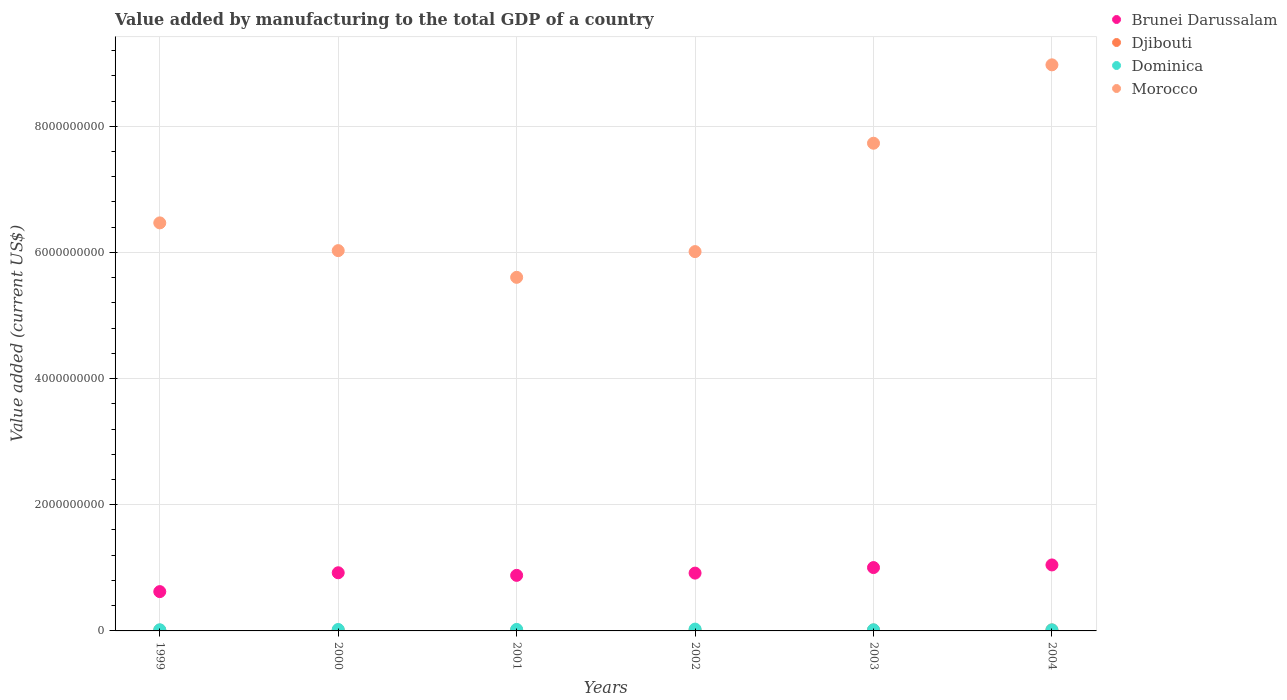What is the value added by manufacturing to the total GDP in Dominica in 2000?
Make the answer very short. 2.29e+07. Across all years, what is the maximum value added by manufacturing to the total GDP in Dominica?
Your response must be concise. 2.89e+07. Across all years, what is the minimum value added by manufacturing to the total GDP in Djibouti?
Your answer should be very brief. 1.21e+07. In which year was the value added by manufacturing to the total GDP in Brunei Darussalam maximum?
Offer a terse response. 2004. What is the total value added by manufacturing to the total GDP in Brunei Darussalam in the graph?
Ensure brevity in your answer.  5.39e+09. What is the difference between the value added by manufacturing to the total GDP in Brunei Darussalam in 2003 and that in 2004?
Your answer should be compact. -4.17e+07. What is the difference between the value added by manufacturing to the total GDP in Djibouti in 1999 and the value added by manufacturing to the total GDP in Morocco in 2001?
Ensure brevity in your answer.  -5.59e+09. What is the average value added by manufacturing to the total GDP in Brunei Darussalam per year?
Your response must be concise. 8.99e+08. In the year 1999, what is the difference between the value added by manufacturing to the total GDP in Dominica and value added by manufacturing to the total GDP in Morocco?
Provide a succinct answer. -6.45e+09. In how many years, is the value added by manufacturing to the total GDP in Dominica greater than 5200000000 US$?
Your answer should be very brief. 0. What is the ratio of the value added by manufacturing to the total GDP in Djibouti in 1999 to that in 2003?
Give a very brief answer. 0.84. What is the difference between the highest and the second highest value added by manufacturing to the total GDP in Dominica?
Provide a short and direct response. 4.72e+06. What is the difference between the highest and the lowest value added by manufacturing to the total GDP in Dominica?
Offer a very short reply. 1.19e+07. Is the sum of the value added by manufacturing to the total GDP in Djibouti in 2001 and 2004 greater than the maximum value added by manufacturing to the total GDP in Dominica across all years?
Ensure brevity in your answer.  No. Does the value added by manufacturing to the total GDP in Djibouti monotonically increase over the years?
Offer a very short reply. Yes. Is the value added by manufacturing to the total GDP in Djibouti strictly greater than the value added by manufacturing to the total GDP in Dominica over the years?
Keep it short and to the point. No. Is the value added by manufacturing to the total GDP in Morocco strictly less than the value added by manufacturing to the total GDP in Djibouti over the years?
Give a very brief answer. No. How many years are there in the graph?
Offer a terse response. 6. Does the graph contain any zero values?
Your answer should be very brief. No. Does the graph contain grids?
Keep it short and to the point. Yes. What is the title of the graph?
Provide a succinct answer. Value added by manufacturing to the total GDP of a country. What is the label or title of the Y-axis?
Provide a short and direct response. Value added (current US$). What is the Value added (current US$) of Brunei Darussalam in 1999?
Offer a very short reply. 6.23e+08. What is the Value added (current US$) of Djibouti in 1999?
Offer a terse response. 1.21e+07. What is the Value added (current US$) in Dominica in 1999?
Provide a succinct answer. 1.83e+07. What is the Value added (current US$) of Morocco in 1999?
Your answer should be very brief. 6.47e+09. What is the Value added (current US$) of Brunei Darussalam in 2000?
Keep it short and to the point. 9.22e+08. What is the Value added (current US$) of Djibouti in 2000?
Your response must be concise. 1.26e+07. What is the Value added (current US$) in Dominica in 2000?
Your answer should be very brief. 2.29e+07. What is the Value added (current US$) of Morocco in 2000?
Offer a terse response. 6.03e+09. What is the Value added (current US$) in Brunei Darussalam in 2001?
Your answer should be compact. 8.81e+08. What is the Value added (current US$) in Djibouti in 2001?
Provide a short and direct response. 1.32e+07. What is the Value added (current US$) of Dominica in 2001?
Make the answer very short. 2.42e+07. What is the Value added (current US$) of Morocco in 2001?
Keep it short and to the point. 5.61e+09. What is the Value added (current US$) of Brunei Darussalam in 2002?
Give a very brief answer. 9.16e+08. What is the Value added (current US$) of Djibouti in 2002?
Your answer should be very brief. 1.37e+07. What is the Value added (current US$) of Dominica in 2002?
Give a very brief answer. 2.89e+07. What is the Value added (current US$) of Morocco in 2002?
Keep it short and to the point. 6.01e+09. What is the Value added (current US$) of Brunei Darussalam in 2003?
Give a very brief answer. 1.00e+09. What is the Value added (current US$) in Djibouti in 2003?
Offer a very short reply. 1.44e+07. What is the Value added (current US$) of Dominica in 2003?
Offer a terse response. 1.80e+07. What is the Value added (current US$) in Morocco in 2003?
Provide a short and direct response. 7.73e+09. What is the Value added (current US$) in Brunei Darussalam in 2004?
Make the answer very short. 1.05e+09. What is the Value added (current US$) in Djibouti in 2004?
Provide a succinct answer. 1.54e+07. What is the Value added (current US$) in Dominica in 2004?
Give a very brief answer. 1.70e+07. What is the Value added (current US$) of Morocco in 2004?
Offer a terse response. 8.97e+09. Across all years, what is the maximum Value added (current US$) in Brunei Darussalam?
Make the answer very short. 1.05e+09. Across all years, what is the maximum Value added (current US$) in Djibouti?
Ensure brevity in your answer.  1.54e+07. Across all years, what is the maximum Value added (current US$) of Dominica?
Give a very brief answer. 2.89e+07. Across all years, what is the maximum Value added (current US$) of Morocco?
Make the answer very short. 8.97e+09. Across all years, what is the minimum Value added (current US$) in Brunei Darussalam?
Offer a terse response. 6.23e+08. Across all years, what is the minimum Value added (current US$) of Djibouti?
Ensure brevity in your answer.  1.21e+07. Across all years, what is the minimum Value added (current US$) in Dominica?
Offer a terse response. 1.70e+07. Across all years, what is the minimum Value added (current US$) in Morocco?
Make the answer very short. 5.61e+09. What is the total Value added (current US$) in Brunei Darussalam in the graph?
Your response must be concise. 5.39e+09. What is the total Value added (current US$) of Djibouti in the graph?
Your answer should be very brief. 8.13e+07. What is the total Value added (current US$) of Dominica in the graph?
Make the answer very short. 1.29e+08. What is the total Value added (current US$) of Morocco in the graph?
Keep it short and to the point. 4.08e+1. What is the difference between the Value added (current US$) in Brunei Darussalam in 1999 and that in 2000?
Provide a succinct answer. -2.99e+08. What is the difference between the Value added (current US$) of Djibouti in 1999 and that in 2000?
Provide a short and direct response. -4.83e+05. What is the difference between the Value added (current US$) in Dominica in 1999 and that in 2000?
Provide a succinct answer. -4.63e+06. What is the difference between the Value added (current US$) in Morocco in 1999 and that in 2000?
Provide a succinct answer. 4.40e+08. What is the difference between the Value added (current US$) of Brunei Darussalam in 1999 and that in 2001?
Offer a very short reply. -2.58e+08. What is the difference between the Value added (current US$) of Djibouti in 1999 and that in 2001?
Provide a short and direct response. -1.10e+06. What is the difference between the Value added (current US$) of Dominica in 1999 and that in 2001?
Offer a terse response. -5.92e+06. What is the difference between the Value added (current US$) in Morocco in 1999 and that in 2001?
Your answer should be compact. 8.63e+08. What is the difference between the Value added (current US$) of Brunei Darussalam in 1999 and that in 2002?
Provide a short and direct response. -2.93e+08. What is the difference between the Value added (current US$) of Djibouti in 1999 and that in 2002?
Your response must be concise. -1.60e+06. What is the difference between the Value added (current US$) in Dominica in 1999 and that in 2002?
Keep it short and to the point. -1.06e+07. What is the difference between the Value added (current US$) in Morocco in 1999 and that in 2002?
Your answer should be very brief. 4.55e+08. What is the difference between the Value added (current US$) in Brunei Darussalam in 1999 and that in 2003?
Your response must be concise. -3.81e+08. What is the difference between the Value added (current US$) of Djibouti in 1999 and that in 2003?
Provide a short and direct response. -2.30e+06. What is the difference between the Value added (current US$) in Dominica in 1999 and that in 2003?
Offer a very short reply. 2.37e+05. What is the difference between the Value added (current US$) in Morocco in 1999 and that in 2003?
Your response must be concise. -1.26e+09. What is the difference between the Value added (current US$) of Brunei Darussalam in 1999 and that in 2004?
Provide a short and direct response. -4.23e+08. What is the difference between the Value added (current US$) in Djibouti in 1999 and that in 2004?
Offer a terse response. -3.34e+06. What is the difference between the Value added (current US$) in Dominica in 1999 and that in 2004?
Ensure brevity in your answer.  1.29e+06. What is the difference between the Value added (current US$) in Morocco in 1999 and that in 2004?
Your answer should be compact. -2.51e+09. What is the difference between the Value added (current US$) in Brunei Darussalam in 2000 and that in 2001?
Provide a succinct answer. 4.12e+07. What is the difference between the Value added (current US$) in Djibouti in 2000 and that in 2001?
Your answer should be very brief. -6.18e+05. What is the difference between the Value added (current US$) of Dominica in 2000 and that in 2001?
Your answer should be compact. -1.28e+06. What is the difference between the Value added (current US$) in Morocco in 2000 and that in 2001?
Give a very brief answer. 4.23e+08. What is the difference between the Value added (current US$) of Brunei Darussalam in 2000 and that in 2002?
Your response must be concise. 5.49e+06. What is the difference between the Value added (current US$) in Djibouti in 2000 and that in 2002?
Give a very brief answer. -1.11e+06. What is the difference between the Value added (current US$) in Dominica in 2000 and that in 2002?
Give a very brief answer. -6.01e+06. What is the difference between the Value added (current US$) in Morocco in 2000 and that in 2002?
Offer a terse response. 1.53e+07. What is the difference between the Value added (current US$) in Brunei Darussalam in 2000 and that in 2003?
Your answer should be very brief. -8.23e+07. What is the difference between the Value added (current US$) of Djibouti in 2000 and that in 2003?
Offer a very short reply. -1.81e+06. What is the difference between the Value added (current US$) of Dominica in 2000 and that in 2003?
Ensure brevity in your answer.  4.87e+06. What is the difference between the Value added (current US$) in Morocco in 2000 and that in 2003?
Provide a succinct answer. -1.70e+09. What is the difference between the Value added (current US$) in Brunei Darussalam in 2000 and that in 2004?
Offer a very short reply. -1.24e+08. What is the difference between the Value added (current US$) in Djibouti in 2000 and that in 2004?
Your answer should be compact. -2.86e+06. What is the difference between the Value added (current US$) in Dominica in 2000 and that in 2004?
Provide a succinct answer. 5.93e+06. What is the difference between the Value added (current US$) in Morocco in 2000 and that in 2004?
Your answer should be compact. -2.95e+09. What is the difference between the Value added (current US$) of Brunei Darussalam in 2001 and that in 2002?
Provide a succinct answer. -3.57e+07. What is the difference between the Value added (current US$) of Djibouti in 2001 and that in 2002?
Your answer should be compact. -4.95e+05. What is the difference between the Value added (current US$) of Dominica in 2001 and that in 2002?
Make the answer very short. -4.72e+06. What is the difference between the Value added (current US$) in Morocco in 2001 and that in 2002?
Provide a succinct answer. -4.08e+08. What is the difference between the Value added (current US$) in Brunei Darussalam in 2001 and that in 2003?
Offer a terse response. -1.23e+08. What is the difference between the Value added (current US$) of Djibouti in 2001 and that in 2003?
Your answer should be compact. -1.20e+06. What is the difference between the Value added (current US$) in Dominica in 2001 and that in 2003?
Offer a very short reply. 6.16e+06. What is the difference between the Value added (current US$) in Morocco in 2001 and that in 2003?
Your answer should be compact. -2.13e+09. What is the difference between the Value added (current US$) of Brunei Darussalam in 2001 and that in 2004?
Provide a succinct answer. -1.65e+08. What is the difference between the Value added (current US$) of Djibouti in 2001 and that in 2004?
Make the answer very short. -2.24e+06. What is the difference between the Value added (current US$) in Dominica in 2001 and that in 2004?
Your answer should be compact. 7.21e+06. What is the difference between the Value added (current US$) in Morocco in 2001 and that in 2004?
Your response must be concise. -3.37e+09. What is the difference between the Value added (current US$) of Brunei Darussalam in 2002 and that in 2003?
Your answer should be very brief. -8.78e+07. What is the difference between the Value added (current US$) of Djibouti in 2002 and that in 2003?
Your response must be concise. -7.02e+05. What is the difference between the Value added (current US$) of Dominica in 2002 and that in 2003?
Offer a terse response. 1.09e+07. What is the difference between the Value added (current US$) of Morocco in 2002 and that in 2003?
Offer a terse response. -1.72e+09. What is the difference between the Value added (current US$) in Brunei Darussalam in 2002 and that in 2004?
Ensure brevity in your answer.  -1.30e+08. What is the difference between the Value added (current US$) in Djibouti in 2002 and that in 2004?
Offer a terse response. -1.75e+06. What is the difference between the Value added (current US$) in Dominica in 2002 and that in 2004?
Your answer should be very brief. 1.19e+07. What is the difference between the Value added (current US$) in Morocco in 2002 and that in 2004?
Your answer should be compact. -2.96e+09. What is the difference between the Value added (current US$) in Brunei Darussalam in 2003 and that in 2004?
Your response must be concise. -4.17e+07. What is the difference between the Value added (current US$) in Djibouti in 2003 and that in 2004?
Give a very brief answer. -1.04e+06. What is the difference between the Value added (current US$) in Dominica in 2003 and that in 2004?
Your answer should be compact. 1.06e+06. What is the difference between the Value added (current US$) in Morocco in 2003 and that in 2004?
Provide a succinct answer. -1.24e+09. What is the difference between the Value added (current US$) of Brunei Darussalam in 1999 and the Value added (current US$) of Djibouti in 2000?
Ensure brevity in your answer.  6.11e+08. What is the difference between the Value added (current US$) of Brunei Darussalam in 1999 and the Value added (current US$) of Dominica in 2000?
Ensure brevity in your answer.  6.00e+08. What is the difference between the Value added (current US$) of Brunei Darussalam in 1999 and the Value added (current US$) of Morocco in 2000?
Your answer should be compact. -5.41e+09. What is the difference between the Value added (current US$) in Djibouti in 1999 and the Value added (current US$) in Dominica in 2000?
Make the answer very short. -1.08e+07. What is the difference between the Value added (current US$) in Djibouti in 1999 and the Value added (current US$) in Morocco in 2000?
Your answer should be very brief. -6.02e+09. What is the difference between the Value added (current US$) of Dominica in 1999 and the Value added (current US$) of Morocco in 2000?
Your response must be concise. -6.01e+09. What is the difference between the Value added (current US$) of Brunei Darussalam in 1999 and the Value added (current US$) of Djibouti in 2001?
Provide a succinct answer. 6.10e+08. What is the difference between the Value added (current US$) of Brunei Darussalam in 1999 and the Value added (current US$) of Dominica in 2001?
Give a very brief answer. 5.99e+08. What is the difference between the Value added (current US$) in Brunei Darussalam in 1999 and the Value added (current US$) in Morocco in 2001?
Offer a very short reply. -4.98e+09. What is the difference between the Value added (current US$) in Djibouti in 1999 and the Value added (current US$) in Dominica in 2001?
Offer a very short reply. -1.21e+07. What is the difference between the Value added (current US$) in Djibouti in 1999 and the Value added (current US$) in Morocco in 2001?
Provide a short and direct response. -5.59e+09. What is the difference between the Value added (current US$) of Dominica in 1999 and the Value added (current US$) of Morocco in 2001?
Keep it short and to the point. -5.59e+09. What is the difference between the Value added (current US$) in Brunei Darussalam in 1999 and the Value added (current US$) in Djibouti in 2002?
Your answer should be very brief. 6.09e+08. What is the difference between the Value added (current US$) of Brunei Darussalam in 1999 and the Value added (current US$) of Dominica in 2002?
Offer a terse response. 5.94e+08. What is the difference between the Value added (current US$) in Brunei Darussalam in 1999 and the Value added (current US$) in Morocco in 2002?
Your response must be concise. -5.39e+09. What is the difference between the Value added (current US$) of Djibouti in 1999 and the Value added (current US$) of Dominica in 2002?
Provide a short and direct response. -1.68e+07. What is the difference between the Value added (current US$) of Djibouti in 1999 and the Value added (current US$) of Morocco in 2002?
Ensure brevity in your answer.  -6.00e+09. What is the difference between the Value added (current US$) of Dominica in 1999 and the Value added (current US$) of Morocco in 2002?
Offer a very short reply. -6.00e+09. What is the difference between the Value added (current US$) in Brunei Darussalam in 1999 and the Value added (current US$) in Djibouti in 2003?
Offer a very short reply. 6.09e+08. What is the difference between the Value added (current US$) in Brunei Darussalam in 1999 and the Value added (current US$) in Dominica in 2003?
Keep it short and to the point. 6.05e+08. What is the difference between the Value added (current US$) of Brunei Darussalam in 1999 and the Value added (current US$) of Morocco in 2003?
Your answer should be compact. -7.11e+09. What is the difference between the Value added (current US$) of Djibouti in 1999 and the Value added (current US$) of Dominica in 2003?
Your answer should be very brief. -5.94e+06. What is the difference between the Value added (current US$) in Djibouti in 1999 and the Value added (current US$) in Morocco in 2003?
Your response must be concise. -7.72e+09. What is the difference between the Value added (current US$) in Dominica in 1999 and the Value added (current US$) in Morocco in 2003?
Provide a short and direct response. -7.71e+09. What is the difference between the Value added (current US$) of Brunei Darussalam in 1999 and the Value added (current US$) of Djibouti in 2004?
Make the answer very short. 6.08e+08. What is the difference between the Value added (current US$) of Brunei Darussalam in 1999 and the Value added (current US$) of Dominica in 2004?
Your response must be concise. 6.06e+08. What is the difference between the Value added (current US$) in Brunei Darussalam in 1999 and the Value added (current US$) in Morocco in 2004?
Provide a short and direct response. -8.35e+09. What is the difference between the Value added (current US$) of Djibouti in 1999 and the Value added (current US$) of Dominica in 2004?
Offer a very short reply. -4.88e+06. What is the difference between the Value added (current US$) of Djibouti in 1999 and the Value added (current US$) of Morocco in 2004?
Keep it short and to the point. -8.96e+09. What is the difference between the Value added (current US$) of Dominica in 1999 and the Value added (current US$) of Morocco in 2004?
Ensure brevity in your answer.  -8.96e+09. What is the difference between the Value added (current US$) of Brunei Darussalam in 2000 and the Value added (current US$) of Djibouti in 2001?
Your answer should be compact. 9.09e+08. What is the difference between the Value added (current US$) of Brunei Darussalam in 2000 and the Value added (current US$) of Dominica in 2001?
Your response must be concise. 8.98e+08. What is the difference between the Value added (current US$) in Brunei Darussalam in 2000 and the Value added (current US$) in Morocco in 2001?
Keep it short and to the point. -4.68e+09. What is the difference between the Value added (current US$) of Djibouti in 2000 and the Value added (current US$) of Dominica in 2001?
Your answer should be compact. -1.16e+07. What is the difference between the Value added (current US$) in Djibouti in 2000 and the Value added (current US$) in Morocco in 2001?
Ensure brevity in your answer.  -5.59e+09. What is the difference between the Value added (current US$) of Dominica in 2000 and the Value added (current US$) of Morocco in 2001?
Ensure brevity in your answer.  -5.58e+09. What is the difference between the Value added (current US$) of Brunei Darussalam in 2000 and the Value added (current US$) of Djibouti in 2002?
Give a very brief answer. 9.08e+08. What is the difference between the Value added (current US$) of Brunei Darussalam in 2000 and the Value added (current US$) of Dominica in 2002?
Provide a short and direct response. 8.93e+08. What is the difference between the Value added (current US$) in Brunei Darussalam in 2000 and the Value added (current US$) in Morocco in 2002?
Your answer should be compact. -5.09e+09. What is the difference between the Value added (current US$) in Djibouti in 2000 and the Value added (current US$) in Dominica in 2002?
Provide a short and direct response. -1.63e+07. What is the difference between the Value added (current US$) of Djibouti in 2000 and the Value added (current US$) of Morocco in 2002?
Keep it short and to the point. -6.00e+09. What is the difference between the Value added (current US$) of Dominica in 2000 and the Value added (current US$) of Morocco in 2002?
Your response must be concise. -5.99e+09. What is the difference between the Value added (current US$) in Brunei Darussalam in 2000 and the Value added (current US$) in Djibouti in 2003?
Keep it short and to the point. 9.08e+08. What is the difference between the Value added (current US$) of Brunei Darussalam in 2000 and the Value added (current US$) of Dominica in 2003?
Provide a short and direct response. 9.04e+08. What is the difference between the Value added (current US$) in Brunei Darussalam in 2000 and the Value added (current US$) in Morocco in 2003?
Ensure brevity in your answer.  -6.81e+09. What is the difference between the Value added (current US$) of Djibouti in 2000 and the Value added (current US$) of Dominica in 2003?
Your answer should be compact. -5.45e+06. What is the difference between the Value added (current US$) of Djibouti in 2000 and the Value added (current US$) of Morocco in 2003?
Make the answer very short. -7.72e+09. What is the difference between the Value added (current US$) in Dominica in 2000 and the Value added (current US$) in Morocco in 2003?
Your answer should be compact. -7.71e+09. What is the difference between the Value added (current US$) in Brunei Darussalam in 2000 and the Value added (current US$) in Djibouti in 2004?
Ensure brevity in your answer.  9.07e+08. What is the difference between the Value added (current US$) in Brunei Darussalam in 2000 and the Value added (current US$) in Dominica in 2004?
Your answer should be very brief. 9.05e+08. What is the difference between the Value added (current US$) of Brunei Darussalam in 2000 and the Value added (current US$) of Morocco in 2004?
Offer a terse response. -8.05e+09. What is the difference between the Value added (current US$) of Djibouti in 2000 and the Value added (current US$) of Dominica in 2004?
Ensure brevity in your answer.  -4.40e+06. What is the difference between the Value added (current US$) of Djibouti in 2000 and the Value added (current US$) of Morocco in 2004?
Offer a very short reply. -8.96e+09. What is the difference between the Value added (current US$) in Dominica in 2000 and the Value added (current US$) in Morocco in 2004?
Offer a very short reply. -8.95e+09. What is the difference between the Value added (current US$) of Brunei Darussalam in 2001 and the Value added (current US$) of Djibouti in 2002?
Offer a terse response. 8.67e+08. What is the difference between the Value added (current US$) in Brunei Darussalam in 2001 and the Value added (current US$) in Dominica in 2002?
Your answer should be compact. 8.52e+08. What is the difference between the Value added (current US$) of Brunei Darussalam in 2001 and the Value added (current US$) of Morocco in 2002?
Ensure brevity in your answer.  -5.13e+09. What is the difference between the Value added (current US$) in Djibouti in 2001 and the Value added (current US$) in Dominica in 2002?
Keep it short and to the point. -1.57e+07. What is the difference between the Value added (current US$) of Djibouti in 2001 and the Value added (current US$) of Morocco in 2002?
Your answer should be compact. -6.00e+09. What is the difference between the Value added (current US$) in Dominica in 2001 and the Value added (current US$) in Morocco in 2002?
Ensure brevity in your answer.  -5.99e+09. What is the difference between the Value added (current US$) in Brunei Darussalam in 2001 and the Value added (current US$) in Djibouti in 2003?
Provide a succinct answer. 8.66e+08. What is the difference between the Value added (current US$) in Brunei Darussalam in 2001 and the Value added (current US$) in Dominica in 2003?
Your response must be concise. 8.63e+08. What is the difference between the Value added (current US$) in Brunei Darussalam in 2001 and the Value added (current US$) in Morocco in 2003?
Your response must be concise. -6.85e+09. What is the difference between the Value added (current US$) in Djibouti in 2001 and the Value added (current US$) in Dominica in 2003?
Your answer should be very brief. -4.83e+06. What is the difference between the Value added (current US$) in Djibouti in 2001 and the Value added (current US$) in Morocco in 2003?
Your answer should be very brief. -7.72e+09. What is the difference between the Value added (current US$) of Dominica in 2001 and the Value added (current US$) of Morocco in 2003?
Offer a very short reply. -7.71e+09. What is the difference between the Value added (current US$) in Brunei Darussalam in 2001 and the Value added (current US$) in Djibouti in 2004?
Make the answer very short. 8.65e+08. What is the difference between the Value added (current US$) in Brunei Darussalam in 2001 and the Value added (current US$) in Dominica in 2004?
Offer a very short reply. 8.64e+08. What is the difference between the Value added (current US$) of Brunei Darussalam in 2001 and the Value added (current US$) of Morocco in 2004?
Give a very brief answer. -8.09e+09. What is the difference between the Value added (current US$) of Djibouti in 2001 and the Value added (current US$) of Dominica in 2004?
Your response must be concise. -3.78e+06. What is the difference between the Value added (current US$) of Djibouti in 2001 and the Value added (current US$) of Morocco in 2004?
Ensure brevity in your answer.  -8.96e+09. What is the difference between the Value added (current US$) of Dominica in 2001 and the Value added (current US$) of Morocco in 2004?
Your response must be concise. -8.95e+09. What is the difference between the Value added (current US$) in Brunei Darussalam in 2002 and the Value added (current US$) in Djibouti in 2003?
Provide a succinct answer. 9.02e+08. What is the difference between the Value added (current US$) of Brunei Darussalam in 2002 and the Value added (current US$) of Dominica in 2003?
Offer a terse response. 8.98e+08. What is the difference between the Value added (current US$) in Brunei Darussalam in 2002 and the Value added (current US$) in Morocco in 2003?
Provide a succinct answer. -6.82e+09. What is the difference between the Value added (current US$) in Djibouti in 2002 and the Value added (current US$) in Dominica in 2003?
Offer a terse response. -4.34e+06. What is the difference between the Value added (current US$) in Djibouti in 2002 and the Value added (current US$) in Morocco in 2003?
Keep it short and to the point. -7.72e+09. What is the difference between the Value added (current US$) in Dominica in 2002 and the Value added (current US$) in Morocco in 2003?
Your answer should be compact. -7.70e+09. What is the difference between the Value added (current US$) of Brunei Darussalam in 2002 and the Value added (current US$) of Djibouti in 2004?
Your answer should be compact. 9.01e+08. What is the difference between the Value added (current US$) in Brunei Darussalam in 2002 and the Value added (current US$) in Dominica in 2004?
Your answer should be very brief. 9.00e+08. What is the difference between the Value added (current US$) of Brunei Darussalam in 2002 and the Value added (current US$) of Morocco in 2004?
Give a very brief answer. -8.06e+09. What is the difference between the Value added (current US$) in Djibouti in 2002 and the Value added (current US$) in Dominica in 2004?
Keep it short and to the point. -3.28e+06. What is the difference between the Value added (current US$) of Djibouti in 2002 and the Value added (current US$) of Morocco in 2004?
Give a very brief answer. -8.96e+09. What is the difference between the Value added (current US$) in Dominica in 2002 and the Value added (current US$) in Morocco in 2004?
Make the answer very short. -8.95e+09. What is the difference between the Value added (current US$) of Brunei Darussalam in 2003 and the Value added (current US$) of Djibouti in 2004?
Keep it short and to the point. 9.89e+08. What is the difference between the Value added (current US$) of Brunei Darussalam in 2003 and the Value added (current US$) of Dominica in 2004?
Provide a short and direct response. 9.87e+08. What is the difference between the Value added (current US$) in Brunei Darussalam in 2003 and the Value added (current US$) in Morocco in 2004?
Provide a succinct answer. -7.97e+09. What is the difference between the Value added (current US$) in Djibouti in 2003 and the Value added (current US$) in Dominica in 2004?
Keep it short and to the point. -2.58e+06. What is the difference between the Value added (current US$) of Djibouti in 2003 and the Value added (current US$) of Morocco in 2004?
Provide a succinct answer. -8.96e+09. What is the difference between the Value added (current US$) in Dominica in 2003 and the Value added (current US$) in Morocco in 2004?
Offer a terse response. -8.96e+09. What is the average Value added (current US$) in Brunei Darussalam per year?
Offer a terse response. 8.99e+08. What is the average Value added (current US$) of Djibouti per year?
Offer a very short reply. 1.36e+07. What is the average Value added (current US$) in Dominica per year?
Your answer should be very brief. 2.15e+07. What is the average Value added (current US$) in Morocco per year?
Your answer should be compact. 6.80e+09. In the year 1999, what is the difference between the Value added (current US$) in Brunei Darussalam and Value added (current US$) in Djibouti?
Provide a short and direct response. 6.11e+08. In the year 1999, what is the difference between the Value added (current US$) of Brunei Darussalam and Value added (current US$) of Dominica?
Your response must be concise. 6.05e+08. In the year 1999, what is the difference between the Value added (current US$) of Brunei Darussalam and Value added (current US$) of Morocco?
Your answer should be compact. -5.85e+09. In the year 1999, what is the difference between the Value added (current US$) in Djibouti and Value added (current US$) in Dominica?
Provide a short and direct response. -6.17e+06. In the year 1999, what is the difference between the Value added (current US$) of Djibouti and Value added (current US$) of Morocco?
Your answer should be very brief. -6.46e+09. In the year 1999, what is the difference between the Value added (current US$) of Dominica and Value added (current US$) of Morocco?
Your response must be concise. -6.45e+09. In the year 2000, what is the difference between the Value added (current US$) of Brunei Darussalam and Value added (current US$) of Djibouti?
Provide a short and direct response. 9.09e+08. In the year 2000, what is the difference between the Value added (current US$) in Brunei Darussalam and Value added (current US$) in Dominica?
Make the answer very short. 8.99e+08. In the year 2000, what is the difference between the Value added (current US$) in Brunei Darussalam and Value added (current US$) in Morocco?
Make the answer very short. -5.11e+09. In the year 2000, what is the difference between the Value added (current US$) of Djibouti and Value added (current US$) of Dominica?
Make the answer very short. -1.03e+07. In the year 2000, what is the difference between the Value added (current US$) in Djibouti and Value added (current US$) in Morocco?
Keep it short and to the point. -6.02e+09. In the year 2000, what is the difference between the Value added (current US$) of Dominica and Value added (current US$) of Morocco?
Your response must be concise. -6.01e+09. In the year 2001, what is the difference between the Value added (current US$) of Brunei Darussalam and Value added (current US$) of Djibouti?
Offer a terse response. 8.68e+08. In the year 2001, what is the difference between the Value added (current US$) of Brunei Darussalam and Value added (current US$) of Dominica?
Offer a terse response. 8.57e+08. In the year 2001, what is the difference between the Value added (current US$) in Brunei Darussalam and Value added (current US$) in Morocco?
Your answer should be very brief. -4.72e+09. In the year 2001, what is the difference between the Value added (current US$) of Djibouti and Value added (current US$) of Dominica?
Provide a succinct answer. -1.10e+07. In the year 2001, what is the difference between the Value added (current US$) in Djibouti and Value added (current US$) in Morocco?
Your response must be concise. -5.59e+09. In the year 2001, what is the difference between the Value added (current US$) in Dominica and Value added (current US$) in Morocco?
Keep it short and to the point. -5.58e+09. In the year 2002, what is the difference between the Value added (current US$) in Brunei Darussalam and Value added (current US$) in Djibouti?
Provide a short and direct response. 9.03e+08. In the year 2002, what is the difference between the Value added (current US$) of Brunei Darussalam and Value added (current US$) of Dominica?
Provide a succinct answer. 8.88e+08. In the year 2002, what is the difference between the Value added (current US$) of Brunei Darussalam and Value added (current US$) of Morocco?
Provide a short and direct response. -5.10e+09. In the year 2002, what is the difference between the Value added (current US$) of Djibouti and Value added (current US$) of Dominica?
Give a very brief answer. -1.52e+07. In the year 2002, what is the difference between the Value added (current US$) of Djibouti and Value added (current US$) of Morocco?
Your answer should be compact. -6.00e+09. In the year 2002, what is the difference between the Value added (current US$) of Dominica and Value added (current US$) of Morocco?
Provide a short and direct response. -5.98e+09. In the year 2003, what is the difference between the Value added (current US$) of Brunei Darussalam and Value added (current US$) of Djibouti?
Your answer should be very brief. 9.90e+08. In the year 2003, what is the difference between the Value added (current US$) of Brunei Darussalam and Value added (current US$) of Dominica?
Provide a succinct answer. 9.86e+08. In the year 2003, what is the difference between the Value added (current US$) in Brunei Darussalam and Value added (current US$) in Morocco?
Your answer should be very brief. -6.73e+09. In the year 2003, what is the difference between the Value added (current US$) of Djibouti and Value added (current US$) of Dominica?
Give a very brief answer. -3.64e+06. In the year 2003, what is the difference between the Value added (current US$) in Djibouti and Value added (current US$) in Morocco?
Make the answer very short. -7.72e+09. In the year 2003, what is the difference between the Value added (current US$) in Dominica and Value added (current US$) in Morocco?
Make the answer very short. -7.71e+09. In the year 2004, what is the difference between the Value added (current US$) of Brunei Darussalam and Value added (current US$) of Djibouti?
Provide a succinct answer. 1.03e+09. In the year 2004, what is the difference between the Value added (current US$) of Brunei Darussalam and Value added (current US$) of Dominica?
Provide a short and direct response. 1.03e+09. In the year 2004, what is the difference between the Value added (current US$) of Brunei Darussalam and Value added (current US$) of Morocco?
Offer a terse response. -7.93e+09. In the year 2004, what is the difference between the Value added (current US$) in Djibouti and Value added (current US$) in Dominica?
Provide a short and direct response. -1.54e+06. In the year 2004, what is the difference between the Value added (current US$) of Djibouti and Value added (current US$) of Morocco?
Offer a terse response. -8.96e+09. In the year 2004, what is the difference between the Value added (current US$) of Dominica and Value added (current US$) of Morocco?
Provide a short and direct response. -8.96e+09. What is the ratio of the Value added (current US$) of Brunei Darussalam in 1999 to that in 2000?
Keep it short and to the point. 0.68. What is the ratio of the Value added (current US$) of Djibouti in 1999 to that in 2000?
Your answer should be very brief. 0.96. What is the ratio of the Value added (current US$) in Dominica in 1999 to that in 2000?
Keep it short and to the point. 0.8. What is the ratio of the Value added (current US$) of Morocco in 1999 to that in 2000?
Your answer should be very brief. 1.07. What is the ratio of the Value added (current US$) of Brunei Darussalam in 1999 to that in 2001?
Provide a succinct answer. 0.71. What is the ratio of the Value added (current US$) in Djibouti in 1999 to that in 2001?
Offer a very short reply. 0.92. What is the ratio of the Value added (current US$) in Dominica in 1999 to that in 2001?
Your answer should be compact. 0.76. What is the ratio of the Value added (current US$) of Morocco in 1999 to that in 2001?
Offer a terse response. 1.15. What is the ratio of the Value added (current US$) of Brunei Darussalam in 1999 to that in 2002?
Provide a short and direct response. 0.68. What is the ratio of the Value added (current US$) in Djibouti in 1999 to that in 2002?
Keep it short and to the point. 0.88. What is the ratio of the Value added (current US$) of Dominica in 1999 to that in 2002?
Keep it short and to the point. 0.63. What is the ratio of the Value added (current US$) in Morocco in 1999 to that in 2002?
Your answer should be compact. 1.08. What is the ratio of the Value added (current US$) of Brunei Darussalam in 1999 to that in 2003?
Provide a succinct answer. 0.62. What is the ratio of the Value added (current US$) of Djibouti in 1999 to that in 2003?
Your answer should be very brief. 0.84. What is the ratio of the Value added (current US$) of Dominica in 1999 to that in 2003?
Offer a very short reply. 1.01. What is the ratio of the Value added (current US$) of Morocco in 1999 to that in 2003?
Give a very brief answer. 0.84. What is the ratio of the Value added (current US$) in Brunei Darussalam in 1999 to that in 2004?
Make the answer very short. 0.6. What is the ratio of the Value added (current US$) of Djibouti in 1999 to that in 2004?
Your answer should be compact. 0.78. What is the ratio of the Value added (current US$) of Dominica in 1999 to that in 2004?
Offer a terse response. 1.08. What is the ratio of the Value added (current US$) in Morocco in 1999 to that in 2004?
Your answer should be compact. 0.72. What is the ratio of the Value added (current US$) of Brunei Darussalam in 2000 to that in 2001?
Give a very brief answer. 1.05. What is the ratio of the Value added (current US$) of Djibouti in 2000 to that in 2001?
Offer a terse response. 0.95. What is the ratio of the Value added (current US$) in Dominica in 2000 to that in 2001?
Give a very brief answer. 0.95. What is the ratio of the Value added (current US$) in Morocco in 2000 to that in 2001?
Your response must be concise. 1.08. What is the ratio of the Value added (current US$) in Brunei Darussalam in 2000 to that in 2002?
Ensure brevity in your answer.  1.01. What is the ratio of the Value added (current US$) of Djibouti in 2000 to that in 2002?
Provide a short and direct response. 0.92. What is the ratio of the Value added (current US$) of Dominica in 2000 to that in 2002?
Offer a very short reply. 0.79. What is the ratio of the Value added (current US$) of Brunei Darussalam in 2000 to that in 2003?
Offer a terse response. 0.92. What is the ratio of the Value added (current US$) of Djibouti in 2000 to that in 2003?
Your answer should be compact. 0.87. What is the ratio of the Value added (current US$) of Dominica in 2000 to that in 2003?
Your answer should be compact. 1.27. What is the ratio of the Value added (current US$) of Morocco in 2000 to that in 2003?
Your response must be concise. 0.78. What is the ratio of the Value added (current US$) of Brunei Darussalam in 2000 to that in 2004?
Offer a terse response. 0.88. What is the ratio of the Value added (current US$) of Djibouti in 2000 to that in 2004?
Provide a short and direct response. 0.81. What is the ratio of the Value added (current US$) in Dominica in 2000 to that in 2004?
Offer a terse response. 1.35. What is the ratio of the Value added (current US$) in Morocco in 2000 to that in 2004?
Offer a very short reply. 0.67. What is the ratio of the Value added (current US$) of Brunei Darussalam in 2001 to that in 2002?
Offer a very short reply. 0.96. What is the ratio of the Value added (current US$) in Djibouti in 2001 to that in 2002?
Your answer should be very brief. 0.96. What is the ratio of the Value added (current US$) of Dominica in 2001 to that in 2002?
Your answer should be very brief. 0.84. What is the ratio of the Value added (current US$) of Morocco in 2001 to that in 2002?
Ensure brevity in your answer.  0.93. What is the ratio of the Value added (current US$) in Brunei Darussalam in 2001 to that in 2003?
Provide a succinct answer. 0.88. What is the ratio of the Value added (current US$) of Djibouti in 2001 to that in 2003?
Your answer should be very brief. 0.92. What is the ratio of the Value added (current US$) of Dominica in 2001 to that in 2003?
Provide a short and direct response. 1.34. What is the ratio of the Value added (current US$) in Morocco in 2001 to that in 2003?
Your answer should be compact. 0.72. What is the ratio of the Value added (current US$) of Brunei Darussalam in 2001 to that in 2004?
Keep it short and to the point. 0.84. What is the ratio of the Value added (current US$) of Djibouti in 2001 to that in 2004?
Offer a very short reply. 0.85. What is the ratio of the Value added (current US$) of Dominica in 2001 to that in 2004?
Your answer should be compact. 1.43. What is the ratio of the Value added (current US$) of Morocco in 2001 to that in 2004?
Give a very brief answer. 0.62. What is the ratio of the Value added (current US$) of Brunei Darussalam in 2002 to that in 2003?
Your answer should be compact. 0.91. What is the ratio of the Value added (current US$) in Djibouti in 2002 to that in 2003?
Your answer should be very brief. 0.95. What is the ratio of the Value added (current US$) in Dominica in 2002 to that in 2003?
Your response must be concise. 1.6. What is the ratio of the Value added (current US$) in Brunei Darussalam in 2002 to that in 2004?
Offer a terse response. 0.88. What is the ratio of the Value added (current US$) of Djibouti in 2002 to that in 2004?
Your answer should be very brief. 0.89. What is the ratio of the Value added (current US$) in Dominica in 2002 to that in 2004?
Ensure brevity in your answer.  1.7. What is the ratio of the Value added (current US$) in Morocco in 2002 to that in 2004?
Provide a short and direct response. 0.67. What is the ratio of the Value added (current US$) in Brunei Darussalam in 2003 to that in 2004?
Offer a terse response. 0.96. What is the ratio of the Value added (current US$) of Djibouti in 2003 to that in 2004?
Offer a very short reply. 0.93. What is the ratio of the Value added (current US$) in Dominica in 2003 to that in 2004?
Make the answer very short. 1.06. What is the ratio of the Value added (current US$) of Morocco in 2003 to that in 2004?
Your answer should be compact. 0.86. What is the difference between the highest and the second highest Value added (current US$) in Brunei Darussalam?
Offer a very short reply. 4.17e+07. What is the difference between the highest and the second highest Value added (current US$) in Djibouti?
Your response must be concise. 1.04e+06. What is the difference between the highest and the second highest Value added (current US$) of Dominica?
Your answer should be compact. 4.72e+06. What is the difference between the highest and the second highest Value added (current US$) of Morocco?
Your response must be concise. 1.24e+09. What is the difference between the highest and the lowest Value added (current US$) in Brunei Darussalam?
Your answer should be very brief. 4.23e+08. What is the difference between the highest and the lowest Value added (current US$) in Djibouti?
Your answer should be very brief. 3.34e+06. What is the difference between the highest and the lowest Value added (current US$) in Dominica?
Your answer should be very brief. 1.19e+07. What is the difference between the highest and the lowest Value added (current US$) of Morocco?
Offer a terse response. 3.37e+09. 